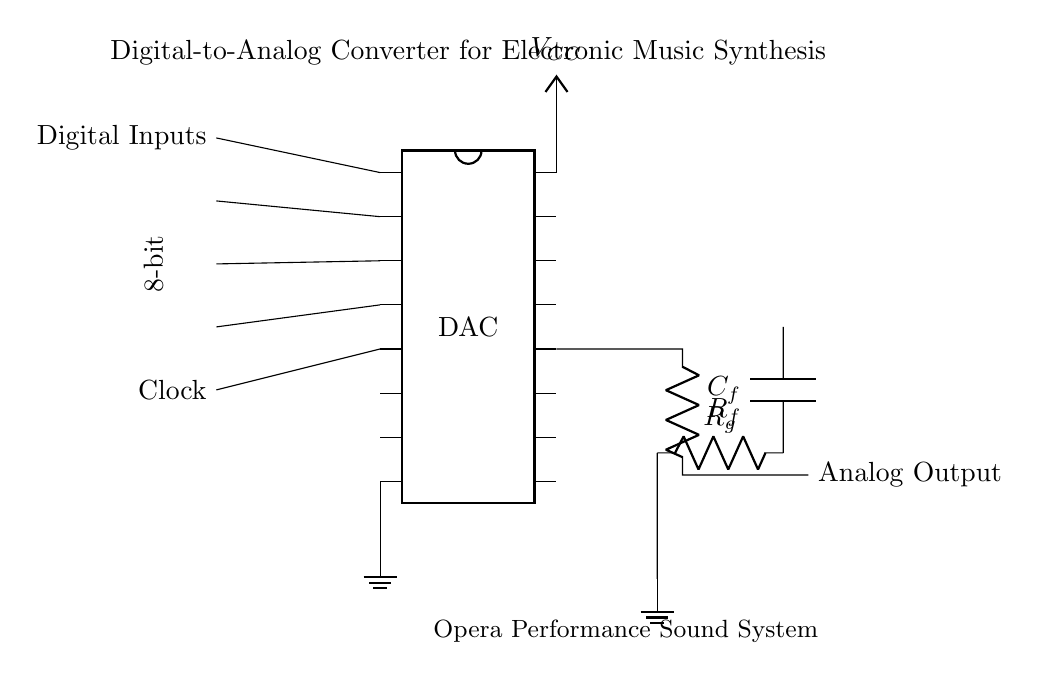What type of converter is depicted in this circuit? The circuit is a Digital-to-Analog Converter, which is indicated by the label on the component in the center. This type of converter takes digital signals as input and converts them to analog signals as output.
Answer: Digital-to-Analog Converter How many digital inputs does the DAC have? The DAC has 4 digital inputs, which are connected to pins 1 to 4 of the DAC component in the circuit diagram. Each connection represents one digital input in the setup.
Answer: 4 What is the role of the capacitor labeled C_f? The capacitor labeled C_f serves as a feedback capacitor in the circuit. Feedback capacitors are commonly used in op-amp circuits to stabilize the output or set the bandwidth, contributing to the conversion process of the DAC.
Answer: Feedback capacitor What does R_f represent in the circuit? R_f represents the feedback resistor in the output stage of the circuit. It is crucial for setting the gain of the op-amp and thus affects the analog output signal generated by the DAC.
Answer: Feedback resistor What is the voltage supply indicated in the circuit? The voltage supply indicated is represented by V_CC, which is connected to pin 16 of the DAC and is typically the power supply voltage needed for proper operation of the DAC circuit.
Answer: V_CC What type of load does the output of the DAC connect to? The output of the DAC connects to an analog output, which typically denotes connection to further audio processing equipment or speakers in the context of electronic music synthesis for performances.
Answer: Analog Output 